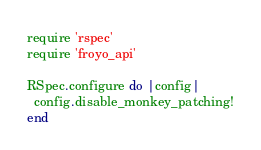Convert code to text. <code><loc_0><loc_0><loc_500><loc_500><_Ruby_>require 'rspec'
require 'froyo_api'

RSpec.configure do |config|
  config.disable_monkey_patching!
end
</code> 